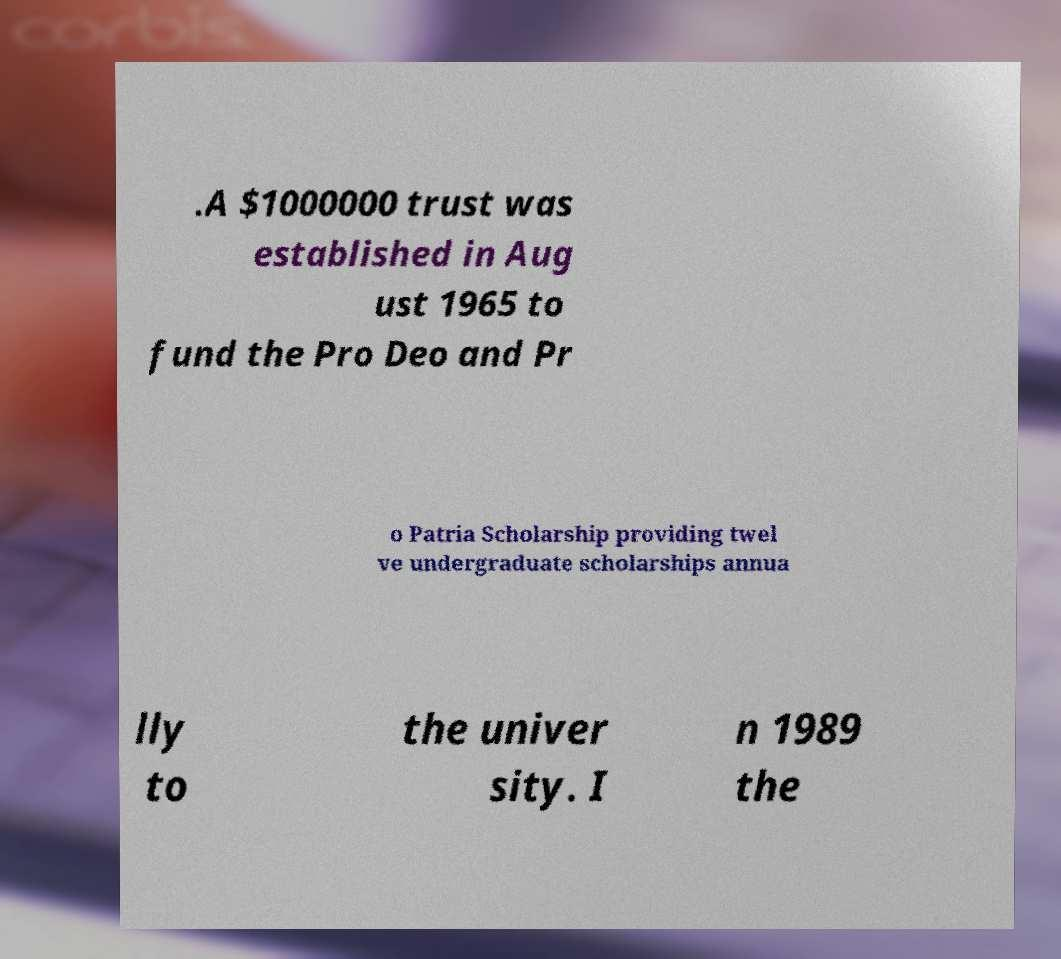What messages or text are displayed in this image? I need them in a readable, typed format. .A $1000000 trust was established in Aug ust 1965 to fund the Pro Deo and Pr o Patria Scholarship providing twel ve undergraduate scholarships annua lly to the univer sity. I n 1989 the 